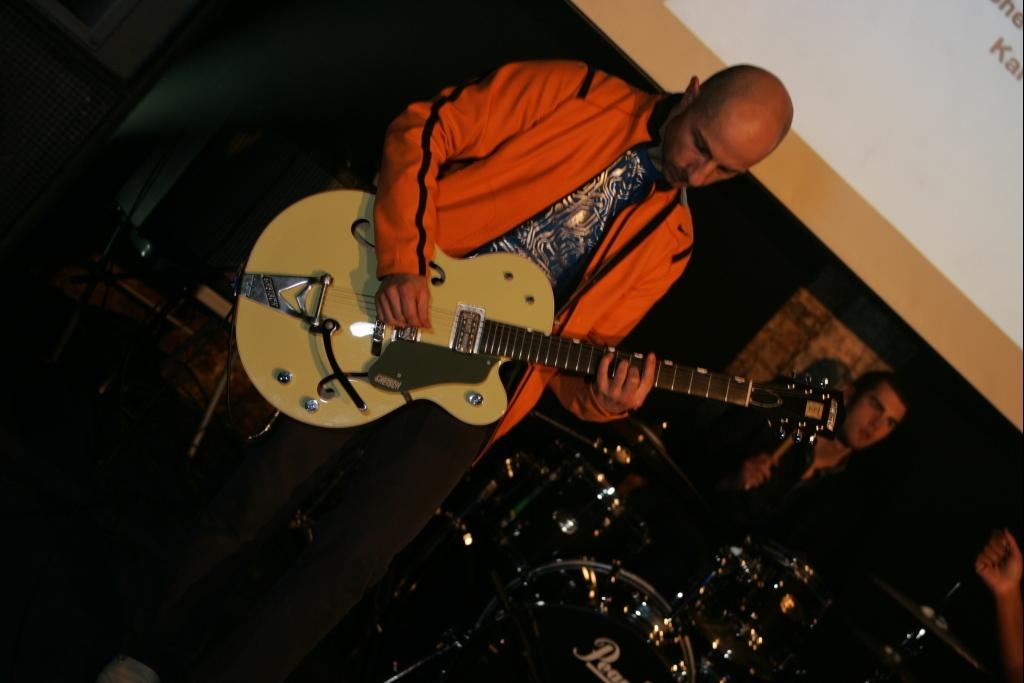Who is the main subject in the image? There is a boy in the image. Where is the boy located? The boy is standing on a stage. What is the boy holding in the image? The boy is holding a guitar. What other musical instrument can be seen in the image? There is a drum set on the right side of the image. Can you see a frog playing the guitar in the image? No, there is no frog present in the image, and the boy is the one playing the guitar. 